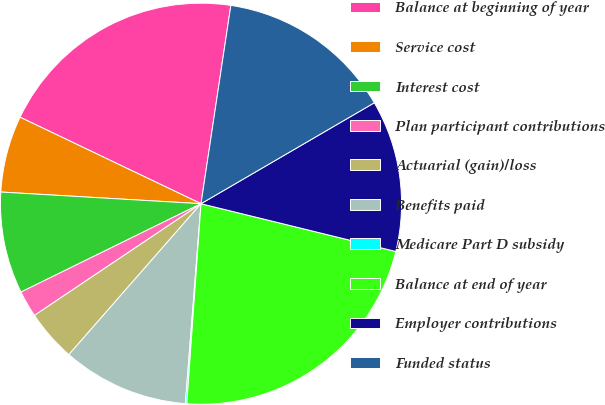Convert chart to OTSL. <chart><loc_0><loc_0><loc_500><loc_500><pie_chart><fcel>Balance at beginning of year<fcel>Service cost<fcel>Interest cost<fcel>Plan participant contributions<fcel>Actuarial (gain)/loss<fcel>Benefits paid<fcel>Medicare Part D subsidy<fcel>Balance at end of year<fcel>Employer contributions<fcel>Funded status<nl><fcel>20.28%<fcel>6.17%<fcel>8.19%<fcel>2.14%<fcel>4.15%<fcel>10.2%<fcel>0.12%<fcel>22.3%<fcel>12.22%<fcel>14.23%<nl></chart> 